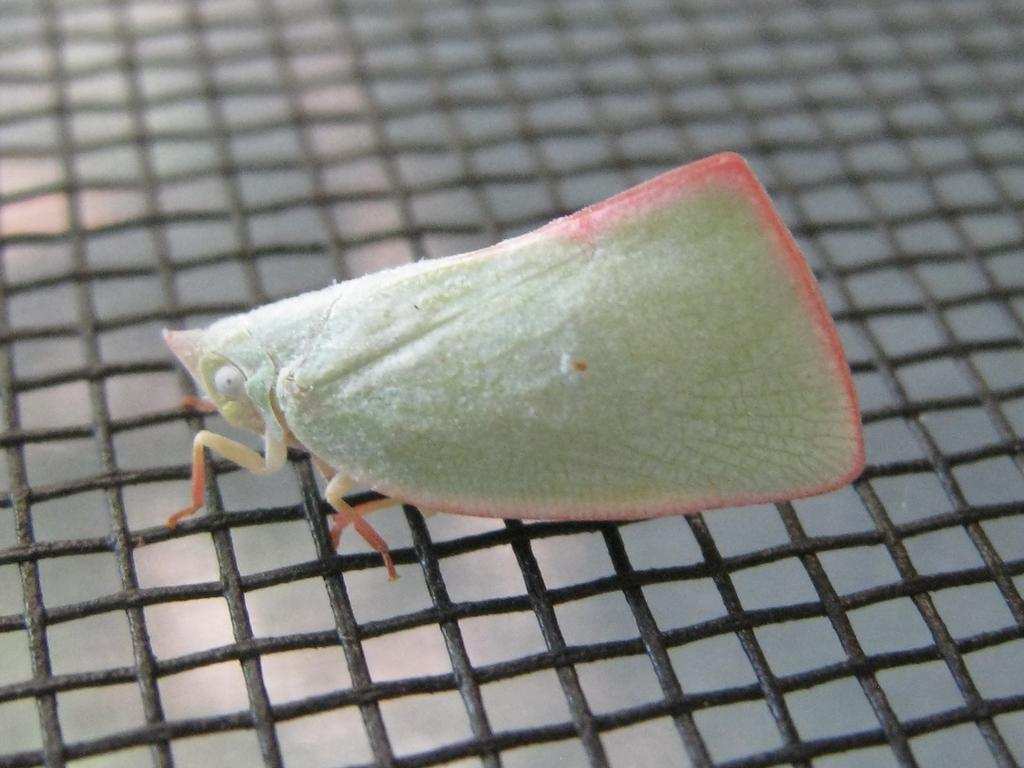What type of creature can be seen in the image? There is an insect in the image. Where is the insect located? The insect is on a mesh. What type of apple can be seen in the image? There is no apple present in the image; it features an insect on a mesh. Is there a dog visible in the image? No, there is no dog present in the image. 